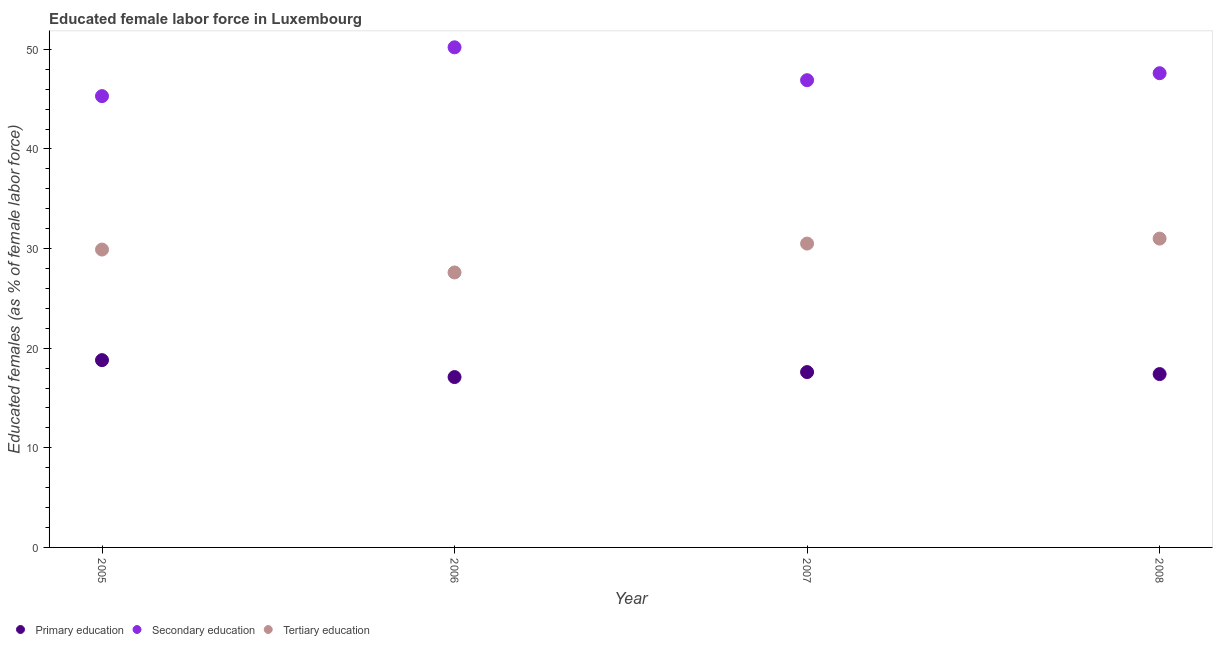What is the percentage of female labor force who received tertiary education in 2005?
Keep it short and to the point. 29.9. Across all years, what is the maximum percentage of female labor force who received primary education?
Keep it short and to the point. 18.8. Across all years, what is the minimum percentage of female labor force who received primary education?
Your response must be concise. 17.1. In which year was the percentage of female labor force who received secondary education minimum?
Make the answer very short. 2005. What is the total percentage of female labor force who received secondary education in the graph?
Provide a short and direct response. 190. What is the difference between the percentage of female labor force who received tertiary education in 2005 and that in 2006?
Provide a short and direct response. 2.3. What is the difference between the percentage of female labor force who received tertiary education in 2006 and the percentage of female labor force who received primary education in 2005?
Your answer should be very brief. 8.8. What is the average percentage of female labor force who received secondary education per year?
Make the answer very short. 47.5. In the year 2006, what is the difference between the percentage of female labor force who received primary education and percentage of female labor force who received tertiary education?
Your answer should be very brief. -10.5. In how many years, is the percentage of female labor force who received secondary education greater than 6 %?
Offer a terse response. 4. What is the ratio of the percentage of female labor force who received secondary education in 2006 to that in 2007?
Your answer should be compact. 1.07. Is the percentage of female labor force who received tertiary education in 2007 less than that in 2008?
Offer a terse response. Yes. What is the difference between the highest and the second highest percentage of female labor force who received secondary education?
Keep it short and to the point. 2.6. What is the difference between the highest and the lowest percentage of female labor force who received primary education?
Keep it short and to the point. 1.7. In how many years, is the percentage of female labor force who received secondary education greater than the average percentage of female labor force who received secondary education taken over all years?
Your answer should be compact. 2. Is it the case that in every year, the sum of the percentage of female labor force who received primary education and percentage of female labor force who received secondary education is greater than the percentage of female labor force who received tertiary education?
Ensure brevity in your answer.  Yes. Is the percentage of female labor force who received primary education strictly less than the percentage of female labor force who received tertiary education over the years?
Your response must be concise. Yes. Are the values on the major ticks of Y-axis written in scientific E-notation?
Your response must be concise. No. Does the graph contain any zero values?
Offer a terse response. No. What is the title of the graph?
Give a very brief answer. Educated female labor force in Luxembourg. What is the label or title of the X-axis?
Make the answer very short. Year. What is the label or title of the Y-axis?
Ensure brevity in your answer.  Educated females (as % of female labor force). What is the Educated females (as % of female labor force) of Primary education in 2005?
Keep it short and to the point. 18.8. What is the Educated females (as % of female labor force) in Secondary education in 2005?
Make the answer very short. 45.3. What is the Educated females (as % of female labor force) in Tertiary education in 2005?
Your answer should be very brief. 29.9. What is the Educated females (as % of female labor force) in Primary education in 2006?
Provide a short and direct response. 17.1. What is the Educated females (as % of female labor force) in Secondary education in 2006?
Offer a very short reply. 50.2. What is the Educated females (as % of female labor force) in Tertiary education in 2006?
Provide a succinct answer. 27.6. What is the Educated females (as % of female labor force) of Primary education in 2007?
Offer a terse response. 17.6. What is the Educated females (as % of female labor force) in Secondary education in 2007?
Your answer should be very brief. 46.9. What is the Educated females (as % of female labor force) of Tertiary education in 2007?
Your answer should be very brief. 30.5. What is the Educated females (as % of female labor force) in Primary education in 2008?
Provide a succinct answer. 17.4. What is the Educated females (as % of female labor force) of Secondary education in 2008?
Ensure brevity in your answer.  47.6. Across all years, what is the maximum Educated females (as % of female labor force) of Primary education?
Offer a terse response. 18.8. Across all years, what is the maximum Educated females (as % of female labor force) in Secondary education?
Ensure brevity in your answer.  50.2. Across all years, what is the maximum Educated females (as % of female labor force) in Tertiary education?
Your response must be concise. 31. Across all years, what is the minimum Educated females (as % of female labor force) in Primary education?
Offer a very short reply. 17.1. Across all years, what is the minimum Educated females (as % of female labor force) in Secondary education?
Your response must be concise. 45.3. Across all years, what is the minimum Educated females (as % of female labor force) in Tertiary education?
Your answer should be very brief. 27.6. What is the total Educated females (as % of female labor force) in Primary education in the graph?
Offer a very short reply. 70.9. What is the total Educated females (as % of female labor force) of Secondary education in the graph?
Provide a succinct answer. 190. What is the total Educated females (as % of female labor force) in Tertiary education in the graph?
Your answer should be very brief. 119. What is the difference between the Educated females (as % of female labor force) in Primary education in 2005 and that in 2006?
Your answer should be compact. 1.7. What is the difference between the Educated females (as % of female labor force) in Secondary education in 2005 and that in 2006?
Your answer should be very brief. -4.9. What is the difference between the Educated females (as % of female labor force) in Primary education in 2005 and that in 2007?
Provide a succinct answer. 1.2. What is the difference between the Educated females (as % of female labor force) in Tertiary education in 2005 and that in 2007?
Keep it short and to the point. -0.6. What is the difference between the Educated females (as % of female labor force) of Primary education in 2005 and that in 2008?
Give a very brief answer. 1.4. What is the difference between the Educated females (as % of female labor force) of Secondary education in 2005 and that in 2008?
Ensure brevity in your answer.  -2.3. What is the difference between the Educated females (as % of female labor force) of Tertiary education in 2005 and that in 2008?
Ensure brevity in your answer.  -1.1. What is the difference between the Educated females (as % of female labor force) in Primary education in 2006 and that in 2007?
Offer a very short reply. -0.5. What is the difference between the Educated females (as % of female labor force) in Secondary education in 2006 and that in 2007?
Make the answer very short. 3.3. What is the difference between the Educated females (as % of female labor force) of Tertiary education in 2006 and that in 2008?
Offer a very short reply. -3.4. What is the difference between the Educated females (as % of female labor force) in Primary education in 2007 and that in 2008?
Give a very brief answer. 0.2. What is the difference between the Educated females (as % of female labor force) in Secondary education in 2007 and that in 2008?
Provide a short and direct response. -0.7. What is the difference between the Educated females (as % of female labor force) in Primary education in 2005 and the Educated females (as % of female labor force) in Secondary education in 2006?
Make the answer very short. -31.4. What is the difference between the Educated females (as % of female labor force) in Primary education in 2005 and the Educated females (as % of female labor force) in Tertiary education in 2006?
Offer a terse response. -8.8. What is the difference between the Educated females (as % of female labor force) in Primary education in 2005 and the Educated females (as % of female labor force) in Secondary education in 2007?
Your response must be concise. -28.1. What is the difference between the Educated females (as % of female labor force) of Primary education in 2005 and the Educated females (as % of female labor force) of Tertiary education in 2007?
Make the answer very short. -11.7. What is the difference between the Educated females (as % of female labor force) in Secondary education in 2005 and the Educated females (as % of female labor force) in Tertiary education in 2007?
Give a very brief answer. 14.8. What is the difference between the Educated females (as % of female labor force) in Primary education in 2005 and the Educated females (as % of female labor force) in Secondary education in 2008?
Give a very brief answer. -28.8. What is the difference between the Educated females (as % of female labor force) of Primary education in 2005 and the Educated females (as % of female labor force) of Tertiary education in 2008?
Your response must be concise. -12.2. What is the difference between the Educated females (as % of female labor force) in Secondary education in 2005 and the Educated females (as % of female labor force) in Tertiary education in 2008?
Provide a succinct answer. 14.3. What is the difference between the Educated females (as % of female labor force) in Primary education in 2006 and the Educated females (as % of female labor force) in Secondary education in 2007?
Your response must be concise. -29.8. What is the difference between the Educated females (as % of female labor force) in Secondary education in 2006 and the Educated females (as % of female labor force) in Tertiary education in 2007?
Provide a succinct answer. 19.7. What is the difference between the Educated females (as % of female labor force) of Primary education in 2006 and the Educated females (as % of female labor force) of Secondary education in 2008?
Give a very brief answer. -30.5. What is the difference between the Educated females (as % of female labor force) in Secondary education in 2006 and the Educated females (as % of female labor force) in Tertiary education in 2008?
Ensure brevity in your answer.  19.2. What is the difference between the Educated females (as % of female labor force) of Primary education in 2007 and the Educated females (as % of female labor force) of Tertiary education in 2008?
Your answer should be very brief. -13.4. What is the difference between the Educated females (as % of female labor force) in Secondary education in 2007 and the Educated females (as % of female labor force) in Tertiary education in 2008?
Your response must be concise. 15.9. What is the average Educated females (as % of female labor force) of Primary education per year?
Keep it short and to the point. 17.73. What is the average Educated females (as % of female labor force) in Secondary education per year?
Ensure brevity in your answer.  47.5. What is the average Educated females (as % of female labor force) in Tertiary education per year?
Offer a terse response. 29.75. In the year 2005, what is the difference between the Educated females (as % of female labor force) in Primary education and Educated females (as % of female labor force) in Secondary education?
Offer a very short reply. -26.5. In the year 2005, what is the difference between the Educated females (as % of female labor force) in Secondary education and Educated females (as % of female labor force) in Tertiary education?
Offer a terse response. 15.4. In the year 2006, what is the difference between the Educated females (as % of female labor force) of Primary education and Educated females (as % of female labor force) of Secondary education?
Give a very brief answer. -33.1. In the year 2006, what is the difference between the Educated females (as % of female labor force) of Primary education and Educated females (as % of female labor force) of Tertiary education?
Your answer should be very brief. -10.5. In the year 2006, what is the difference between the Educated females (as % of female labor force) in Secondary education and Educated females (as % of female labor force) in Tertiary education?
Make the answer very short. 22.6. In the year 2007, what is the difference between the Educated females (as % of female labor force) in Primary education and Educated females (as % of female labor force) in Secondary education?
Ensure brevity in your answer.  -29.3. In the year 2007, what is the difference between the Educated females (as % of female labor force) of Secondary education and Educated females (as % of female labor force) of Tertiary education?
Your answer should be very brief. 16.4. In the year 2008, what is the difference between the Educated females (as % of female labor force) in Primary education and Educated females (as % of female labor force) in Secondary education?
Offer a very short reply. -30.2. What is the ratio of the Educated females (as % of female labor force) in Primary education in 2005 to that in 2006?
Offer a terse response. 1.1. What is the ratio of the Educated females (as % of female labor force) of Secondary education in 2005 to that in 2006?
Provide a succinct answer. 0.9. What is the ratio of the Educated females (as % of female labor force) in Tertiary education in 2005 to that in 2006?
Your answer should be compact. 1.08. What is the ratio of the Educated females (as % of female labor force) of Primary education in 2005 to that in 2007?
Offer a very short reply. 1.07. What is the ratio of the Educated females (as % of female labor force) of Secondary education in 2005 to that in 2007?
Your answer should be very brief. 0.97. What is the ratio of the Educated females (as % of female labor force) in Tertiary education in 2005 to that in 2007?
Offer a terse response. 0.98. What is the ratio of the Educated females (as % of female labor force) in Primary education in 2005 to that in 2008?
Ensure brevity in your answer.  1.08. What is the ratio of the Educated females (as % of female labor force) of Secondary education in 2005 to that in 2008?
Your response must be concise. 0.95. What is the ratio of the Educated females (as % of female labor force) in Tertiary education in 2005 to that in 2008?
Provide a succinct answer. 0.96. What is the ratio of the Educated females (as % of female labor force) in Primary education in 2006 to that in 2007?
Give a very brief answer. 0.97. What is the ratio of the Educated females (as % of female labor force) in Secondary education in 2006 to that in 2007?
Provide a short and direct response. 1.07. What is the ratio of the Educated females (as % of female labor force) in Tertiary education in 2006 to that in 2007?
Offer a very short reply. 0.9. What is the ratio of the Educated females (as % of female labor force) in Primary education in 2006 to that in 2008?
Make the answer very short. 0.98. What is the ratio of the Educated females (as % of female labor force) of Secondary education in 2006 to that in 2008?
Keep it short and to the point. 1.05. What is the ratio of the Educated females (as % of female labor force) in Tertiary education in 2006 to that in 2008?
Provide a succinct answer. 0.89. What is the ratio of the Educated females (as % of female labor force) of Primary education in 2007 to that in 2008?
Offer a terse response. 1.01. What is the ratio of the Educated females (as % of female labor force) of Secondary education in 2007 to that in 2008?
Make the answer very short. 0.99. What is the ratio of the Educated females (as % of female labor force) of Tertiary education in 2007 to that in 2008?
Offer a very short reply. 0.98. What is the difference between the highest and the second highest Educated females (as % of female labor force) in Tertiary education?
Provide a short and direct response. 0.5. What is the difference between the highest and the lowest Educated females (as % of female labor force) in Secondary education?
Your answer should be very brief. 4.9. 